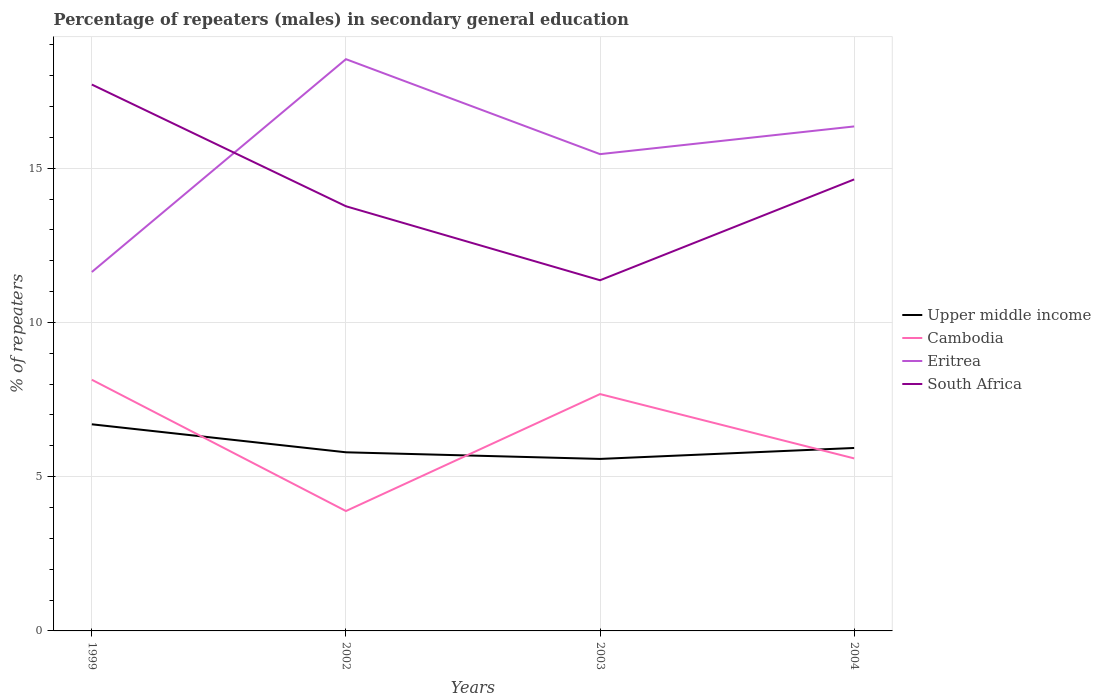Does the line corresponding to Upper middle income intersect with the line corresponding to South Africa?
Provide a succinct answer. No. Is the number of lines equal to the number of legend labels?
Offer a terse response. Yes. Across all years, what is the maximum percentage of male repeaters in Eritrea?
Provide a short and direct response. 11.64. What is the total percentage of male repeaters in Cambodia in the graph?
Make the answer very short. -3.79. What is the difference between the highest and the second highest percentage of male repeaters in Eritrea?
Offer a very short reply. 6.9. What is the difference between the highest and the lowest percentage of male repeaters in Eritrea?
Offer a very short reply. 2. How many lines are there?
Offer a terse response. 4. How many years are there in the graph?
Make the answer very short. 4. Are the values on the major ticks of Y-axis written in scientific E-notation?
Offer a terse response. No. Does the graph contain any zero values?
Your response must be concise. No. Does the graph contain grids?
Offer a terse response. Yes. Where does the legend appear in the graph?
Provide a succinct answer. Center right. How many legend labels are there?
Ensure brevity in your answer.  4. What is the title of the graph?
Ensure brevity in your answer.  Percentage of repeaters (males) in secondary general education. What is the label or title of the X-axis?
Provide a succinct answer. Years. What is the label or title of the Y-axis?
Ensure brevity in your answer.  % of repeaters. What is the % of repeaters of Upper middle income in 1999?
Keep it short and to the point. 6.7. What is the % of repeaters of Cambodia in 1999?
Keep it short and to the point. 8.14. What is the % of repeaters of Eritrea in 1999?
Ensure brevity in your answer.  11.64. What is the % of repeaters in South Africa in 1999?
Provide a succinct answer. 17.71. What is the % of repeaters in Upper middle income in 2002?
Your answer should be very brief. 5.79. What is the % of repeaters in Cambodia in 2002?
Offer a terse response. 3.89. What is the % of repeaters in Eritrea in 2002?
Ensure brevity in your answer.  18.54. What is the % of repeaters of South Africa in 2002?
Keep it short and to the point. 13.77. What is the % of repeaters of Upper middle income in 2003?
Make the answer very short. 5.58. What is the % of repeaters of Cambodia in 2003?
Your answer should be compact. 7.68. What is the % of repeaters of Eritrea in 2003?
Provide a succinct answer. 15.46. What is the % of repeaters in South Africa in 2003?
Give a very brief answer. 11.37. What is the % of repeaters in Upper middle income in 2004?
Provide a short and direct response. 5.93. What is the % of repeaters in Cambodia in 2004?
Offer a terse response. 5.59. What is the % of repeaters of Eritrea in 2004?
Provide a short and direct response. 16.35. What is the % of repeaters in South Africa in 2004?
Give a very brief answer. 14.64. Across all years, what is the maximum % of repeaters in Upper middle income?
Offer a terse response. 6.7. Across all years, what is the maximum % of repeaters in Cambodia?
Your answer should be very brief. 8.14. Across all years, what is the maximum % of repeaters in Eritrea?
Your response must be concise. 18.54. Across all years, what is the maximum % of repeaters of South Africa?
Your answer should be compact. 17.71. Across all years, what is the minimum % of repeaters in Upper middle income?
Give a very brief answer. 5.58. Across all years, what is the minimum % of repeaters of Cambodia?
Offer a very short reply. 3.89. Across all years, what is the minimum % of repeaters in Eritrea?
Offer a very short reply. 11.64. Across all years, what is the minimum % of repeaters in South Africa?
Your response must be concise. 11.37. What is the total % of repeaters in Upper middle income in the graph?
Offer a very short reply. 24. What is the total % of repeaters in Cambodia in the graph?
Your response must be concise. 25.3. What is the total % of repeaters of Eritrea in the graph?
Your answer should be compact. 61.98. What is the total % of repeaters of South Africa in the graph?
Your answer should be compact. 57.49. What is the difference between the % of repeaters of Upper middle income in 1999 and that in 2002?
Make the answer very short. 0.91. What is the difference between the % of repeaters in Cambodia in 1999 and that in 2002?
Ensure brevity in your answer.  4.26. What is the difference between the % of repeaters in Eritrea in 1999 and that in 2002?
Your response must be concise. -6.9. What is the difference between the % of repeaters in South Africa in 1999 and that in 2002?
Keep it short and to the point. 3.95. What is the difference between the % of repeaters in Upper middle income in 1999 and that in 2003?
Provide a succinct answer. 1.12. What is the difference between the % of repeaters in Cambodia in 1999 and that in 2003?
Your answer should be compact. 0.46. What is the difference between the % of repeaters in Eritrea in 1999 and that in 2003?
Your answer should be compact. -3.82. What is the difference between the % of repeaters in South Africa in 1999 and that in 2003?
Ensure brevity in your answer.  6.34. What is the difference between the % of repeaters in Upper middle income in 1999 and that in 2004?
Provide a short and direct response. 0.77. What is the difference between the % of repeaters of Cambodia in 1999 and that in 2004?
Provide a succinct answer. 2.55. What is the difference between the % of repeaters in Eritrea in 1999 and that in 2004?
Make the answer very short. -4.72. What is the difference between the % of repeaters in South Africa in 1999 and that in 2004?
Ensure brevity in your answer.  3.08. What is the difference between the % of repeaters of Upper middle income in 2002 and that in 2003?
Your answer should be compact. 0.21. What is the difference between the % of repeaters of Cambodia in 2002 and that in 2003?
Provide a succinct answer. -3.79. What is the difference between the % of repeaters of Eritrea in 2002 and that in 2003?
Offer a terse response. 3.08. What is the difference between the % of repeaters of South Africa in 2002 and that in 2003?
Provide a short and direct response. 2.4. What is the difference between the % of repeaters of Upper middle income in 2002 and that in 2004?
Provide a short and direct response. -0.14. What is the difference between the % of repeaters in Cambodia in 2002 and that in 2004?
Offer a terse response. -1.71. What is the difference between the % of repeaters of Eritrea in 2002 and that in 2004?
Your response must be concise. 2.18. What is the difference between the % of repeaters in South Africa in 2002 and that in 2004?
Offer a very short reply. -0.87. What is the difference between the % of repeaters of Upper middle income in 2003 and that in 2004?
Your answer should be compact. -0.35. What is the difference between the % of repeaters in Cambodia in 2003 and that in 2004?
Ensure brevity in your answer.  2.09. What is the difference between the % of repeaters of Eritrea in 2003 and that in 2004?
Keep it short and to the point. -0.9. What is the difference between the % of repeaters in South Africa in 2003 and that in 2004?
Make the answer very short. -3.27. What is the difference between the % of repeaters in Upper middle income in 1999 and the % of repeaters in Cambodia in 2002?
Give a very brief answer. 2.81. What is the difference between the % of repeaters in Upper middle income in 1999 and the % of repeaters in Eritrea in 2002?
Give a very brief answer. -11.84. What is the difference between the % of repeaters of Upper middle income in 1999 and the % of repeaters of South Africa in 2002?
Your answer should be very brief. -7.07. What is the difference between the % of repeaters in Cambodia in 1999 and the % of repeaters in Eritrea in 2002?
Your answer should be compact. -10.39. What is the difference between the % of repeaters of Cambodia in 1999 and the % of repeaters of South Africa in 2002?
Offer a terse response. -5.62. What is the difference between the % of repeaters of Eritrea in 1999 and the % of repeaters of South Africa in 2002?
Your answer should be compact. -2.13. What is the difference between the % of repeaters in Upper middle income in 1999 and the % of repeaters in Cambodia in 2003?
Offer a terse response. -0.98. What is the difference between the % of repeaters of Upper middle income in 1999 and the % of repeaters of Eritrea in 2003?
Provide a short and direct response. -8.76. What is the difference between the % of repeaters in Upper middle income in 1999 and the % of repeaters in South Africa in 2003?
Offer a terse response. -4.67. What is the difference between the % of repeaters of Cambodia in 1999 and the % of repeaters of Eritrea in 2003?
Provide a short and direct response. -7.31. What is the difference between the % of repeaters of Cambodia in 1999 and the % of repeaters of South Africa in 2003?
Provide a short and direct response. -3.23. What is the difference between the % of repeaters of Eritrea in 1999 and the % of repeaters of South Africa in 2003?
Provide a succinct answer. 0.27. What is the difference between the % of repeaters of Upper middle income in 1999 and the % of repeaters of Cambodia in 2004?
Make the answer very short. 1.11. What is the difference between the % of repeaters of Upper middle income in 1999 and the % of repeaters of Eritrea in 2004?
Give a very brief answer. -9.66. What is the difference between the % of repeaters of Upper middle income in 1999 and the % of repeaters of South Africa in 2004?
Provide a short and direct response. -7.94. What is the difference between the % of repeaters of Cambodia in 1999 and the % of repeaters of Eritrea in 2004?
Make the answer very short. -8.21. What is the difference between the % of repeaters in Cambodia in 1999 and the % of repeaters in South Africa in 2004?
Provide a short and direct response. -6.49. What is the difference between the % of repeaters in Eritrea in 1999 and the % of repeaters in South Africa in 2004?
Provide a short and direct response. -3. What is the difference between the % of repeaters in Upper middle income in 2002 and the % of repeaters in Cambodia in 2003?
Provide a short and direct response. -1.89. What is the difference between the % of repeaters in Upper middle income in 2002 and the % of repeaters in Eritrea in 2003?
Your answer should be compact. -9.67. What is the difference between the % of repeaters in Upper middle income in 2002 and the % of repeaters in South Africa in 2003?
Your answer should be compact. -5.58. What is the difference between the % of repeaters in Cambodia in 2002 and the % of repeaters in Eritrea in 2003?
Make the answer very short. -11.57. What is the difference between the % of repeaters in Cambodia in 2002 and the % of repeaters in South Africa in 2003?
Your answer should be compact. -7.48. What is the difference between the % of repeaters in Eritrea in 2002 and the % of repeaters in South Africa in 2003?
Give a very brief answer. 7.17. What is the difference between the % of repeaters in Upper middle income in 2002 and the % of repeaters in Cambodia in 2004?
Make the answer very short. 0.2. What is the difference between the % of repeaters in Upper middle income in 2002 and the % of repeaters in Eritrea in 2004?
Make the answer very short. -10.56. What is the difference between the % of repeaters in Upper middle income in 2002 and the % of repeaters in South Africa in 2004?
Keep it short and to the point. -8.85. What is the difference between the % of repeaters in Cambodia in 2002 and the % of repeaters in Eritrea in 2004?
Your response must be concise. -12.47. What is the difference between the % of repeaters of Cambodia in 2002 and the % of repeaters of South Africa in 2004?
Your answer should be very brief. -10.75. What is the difference between the % of repeaters of Eritrea in 2002 and the % of repeaters of South Africa in 2004?
Make the answer very short. 3.9. What is the difference between the % of repeaters of Upper middle income in 2003 and the % of repeaters of Cambodia in 2004?
Your answer should be compact. -0.02. What is the difference between the % of repeaters in Upper middle income in 2003 and the % of repeaters in Eritrea in 2004?
Provide a short and direct response. -10.78. What is the difference between the % of repeaters of Upper middle income in 2003 and the % of repeaters of South Africa in 2004?
Provide a succinct answer. -9.06. What is the difference between the % of repeaters in Cambodia in 2003 and the % of repeaters in Eritrea in 2004?
Offer a very short reply. -8.68. What is the difference between the % of repeaters in Cambodia in 2003 and the % of repeaters in South Africa in 2004?
Keep it short and to the point. -6.96. What is the difference between the % of repeaters of Eritrea in 2003 and the % of repeaters of South Africa in 2004?
Your response must be concise. 0.82. What is the average % of repeaters in Upper middle income per year?
Give a very brief answer. 6. What is the average % of repeaters in Cambodia per year?
Make the answer very short. 6.33. What is the average % of repeaters of Eritrea per year?
Offer a very short reply. 15.5. What is the average % of repeaters in South Africa per year?
Offer a very short reply. 14.37. In the year 1999, what is the difference between the % of repeaters in Upper middle income and % of repeaters in Cambodia?
Your answer should be very brief. -1.44. In the year 1999, what is the difference between the % of repeaters of Upper middle income and % of repeaters of Eritrea?
Offer a very short reply. -4.94. In the year 1999, what is the difference between the % of repeaters of Upper middle income and % of repeaters of South Africa?
Make the answer very short. -11.01. In the year 1999, what is the difference between the % of repeaters in Cambodia and % of repeaters in Eritrea?
Provide a short and direct response. -3.49. In the year 1999, what is the difference between the % of repeaters in Cambodia and % of repeaters in South Africa?
Provide a succinct answer. -9.57. In the year 1999, what is the difference between the % of repeaters in Eritrea and % of repeaters in South Africa?
Your answer should be compact. -6.08. In the year 2002, what is the difference between the % of repeaters in Upper middle income and % of repeaters in Cambodia?
Keep it short and to the point. 1.9. In the year 2002, what is the difference between the % of repeaters of Upper middle income and % of repeaters of Eritrea?
Your answer should be compact. -12.74. In the year 2002, what is the difference between the % of repeaters of Upper middle income and % of repeaters of South Africa?
Provide a short and direct response. -7.98. In the year 2002, what is the difference between the % of repeaters in Cambodia and % of repeaters in Eritrea?
Provide a short and direct response. -14.65. In the year 2002, what is the difference between the % of repeaters in Cambodia and % of repeaters in South Africa?
Keep it short and to the point. -9.88. In the year 2002, what is the difference between the % of repeaters in Eritrea and % of repeaters in South Africa?
Make the answer very short. 4.77. In the year 2003, what is the difference between the % of repeaters in Upper middle income and % of repeaters in Cambodia?
Provide a short and direct response. -2.1. In the year 2003, what is the difference between the % of repeaters in Upper middle income and % of repeaters in Eritrea?
Your answer should be very brief. -9.88. In the year 2003, what is the difference between the % of repeaters in Upper middle income and % of repeaters in South Africa?
Provide a short and direct response. -5.79. In the year 2003, what is the difference between the % of repeaters of Cambodia and % of repeaters of Eritrea?
Give a very brief answer. -7.78. In the year 2003, what is the difference between the % of repeaters in Cambodia and % of repeaters in South Africa?
Make the answer very short. -3.69. In the year 2003, what is the difference between the % of repeaters in Eritrea and % of repeaters in South Africa?
Your answer should be very brief. 4.09. In the year 2004, what is the difference between the % of repeaters in Upper middle income and % of repeaters in Cambodia?
Ensure brevity in your answer.  0.34. In the year 2004, what is the difference between the % of repeaters of Upper middle income and % of repeaters of Eritrea?
Your answer should be very brief. -10.42. In the year 2004, what is the difference between the % of repeaters in Upper middle income and % of repeaters in South Africa?
Make the answer very short. -8.71. In the year 2004, what is the difference between the % of repeaters of Cambodia and % of repeaters of Eritrea?
Make the answer very short. -10.76. In the year 2004, what is the difference between the % of repeaters of Cambodia and % of repeaters of South Africa?
Provide a short and direct response. -9.04. In the year 2004, what is the difference between the % of repeaters of Eritrea and % of repeaters of South Africa?
Your response must be concise. 1.72. What is the ratio of the % of repeaters of Upper middle income in 1999 to that in 2002?
Your answer should be very brief. 1.16. What is the ratio of the % of repeaters of Cambodia in 1999 to that in 2002?
Provide a succinct answer. 2.1. What is the ratio of the % of repeaters of Eritrea in 1999 to that in 2002?
Ensure brevity in your answer.  0.63. What is the ratio of the % of repeaters of South Africa in 1999 to that in 2002?
Keep it short and to the point. 1.29. What is the ratio of the % of repeaters of Upper middle income in 1999 to that in 2003?
Make the answer very short. 1.2. What is the ratio of the % of repeaters of Cambodia in 1999 to that in 2003?
Provide a short and direct response. 1.06. What is the ratio of the % of repeaters of Eritrea in 1999 to that in 2003?
Keep it short and to the point. 0.75. What is the ratio of the % of repeaters of South Africa in 1999 to that in 2003?
Make the answer very short. 1.56. What is the ratio of the % of repeaters in Upper middle income in 1999 to that in 2004?
Offer a terse response. 1.13. What is the ratio of the % of repeaters of Cambodia in 1999 to that in 2004?
Your response must be concise. 1.46. What is the ratio of the % of repeaters in Eritrea in 1999 to that in 2004?
Ensure brevity in your answer.  0.71. What is the ratio of the % of repeaters in South Africa in 1999 to that in 2004?
Offer a very short reply. 1.21. What is the ratio of the % of repeaters in Upper middle income in 2002 to that in 2003?
Provide a short and direct response. 1.04. What is the ratio of the % of repeaters in Cambodia in 2002 to that in 2003?
Ensure brevity in your answer.  0.51. What is the ratio of the % of repeaters of Eritrea in 2002 to that in 2003?
Make the answer very short. 1.2. What is the ratio of the % of repeaters in South Africa in 2002 to that in 2003?
Ensure brevity in your answer.  1.21. What is the ratio of the % of repeaters in Upper middle income in 2002 to that in 2004?
Provide a succinct answer. 0.98. What is the ratio of the % of repeaters in Cambodia in 2002 to that in 2004?
Provide a short and direct response. 0.69. What is the ratio of the % of repeaters in Eritrea in 2002 to that in 2004?
Offer a very short reply. 1.13. What is the ratio of the % of repeaters in South Africa in 2002 to that in 2004?
Ensure brevity in your answer.  0.94. What is the ratio of the % of repeaters of Upper middle income in 2003 to that in 2004?
Make the answer very short. 0.94. What is the ratio of the % of repeaters in Cambodia in 2003 to that in 2004?
Offer a terse response. 1.37. What is the ratio of the % of repeaters of Eritrea in 2003 to that in 2004?
Give a very brief answer. 0.95. What is the ratio of the % of repeaters of South Africa in 2003 to that in 2004?
Your response must be concise. 0.78. What is the difference between the highest and the second highest % of repeaters of Upper middle income?
Offer a very short reply. 0.77. What is the difference between the highest and the second highest % of repeaters in Cambodia?
Provide a short and direct response. 0.46. What is the difference between the highest and the second highest % of repeaters in Eritrea?
Your answer should be compact. 2.18. What is the difference between the highest and the second highest % of repeaters in South Africa?
Offer a very short reply. 3.08. What is the difference between the highest and the lowest % of repeaters in Upper middle income?
Provide a succinct answer. 1.12. What is the difference between the highest and the lowest % of repeaters of Cambodia?
Your answer should be compact. 4.26. What is the difference between the highest and the lowest % of repeaters in Eritrea?
Provide a short and direct response. 6.9. What is the difference between the highest and the lowest % of repeaters in South Africa?
Make the answer very short. 6.34. 